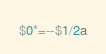Convert code to text. <code><loc_0><loc_0><loc_500><loc_500><_Awk_>$0*=--$1/2a</code> 